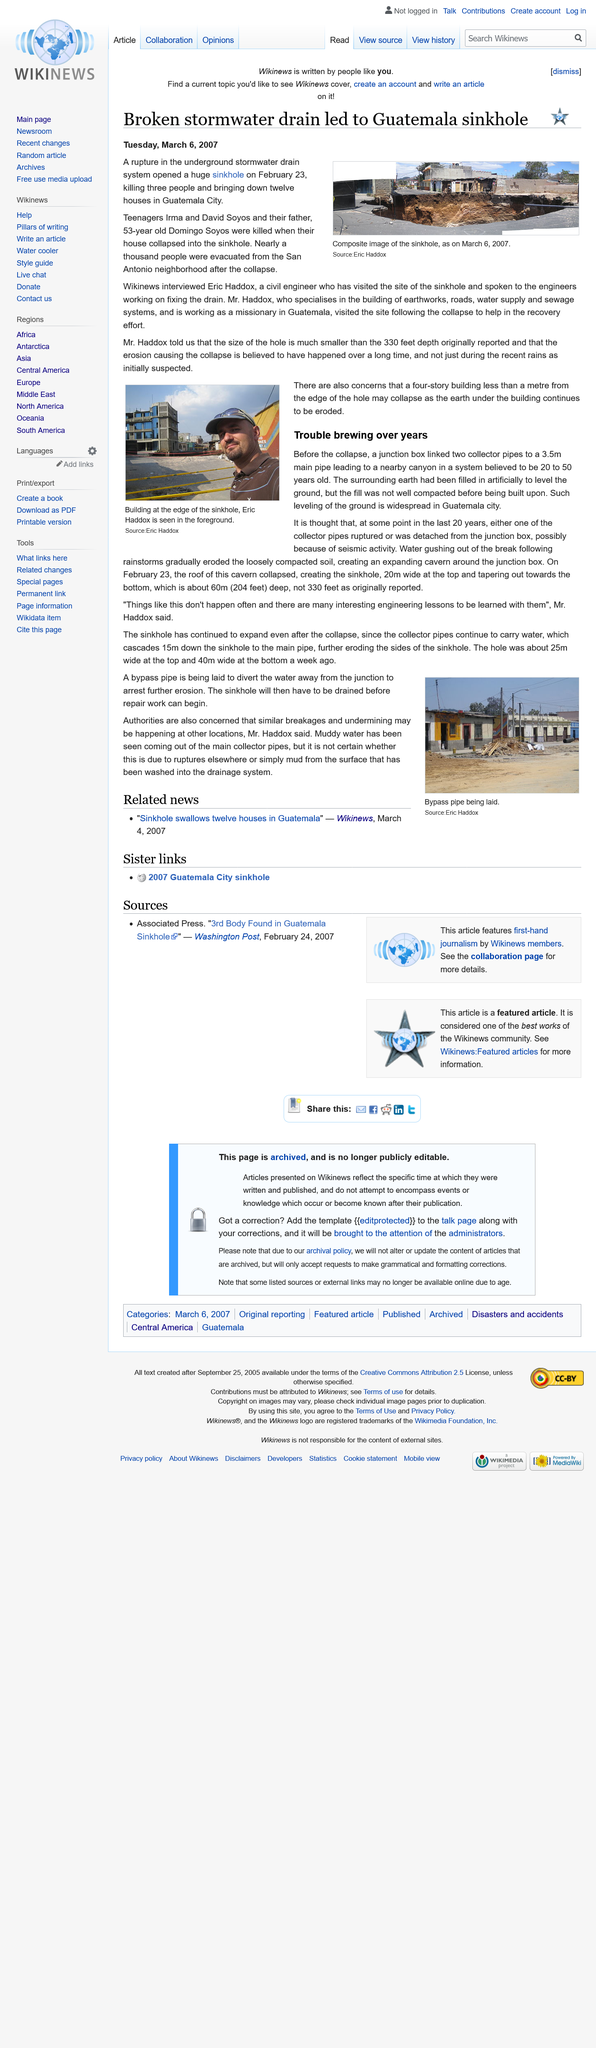Point out several critical features in this image. The collector pipes are believed to have ruptured as a result of seismic activity, causing them to detach from the junction box. The image depicts a building situated on the edge of a sinkhole, with Eric Haddox visible in the foreground. This article was published on March 6th, 2007, as indicated by the date format of DD/MM/YYYY. The incident occurred in Guatemala. A rupture in a stormwater drain caused the sinkhole. 